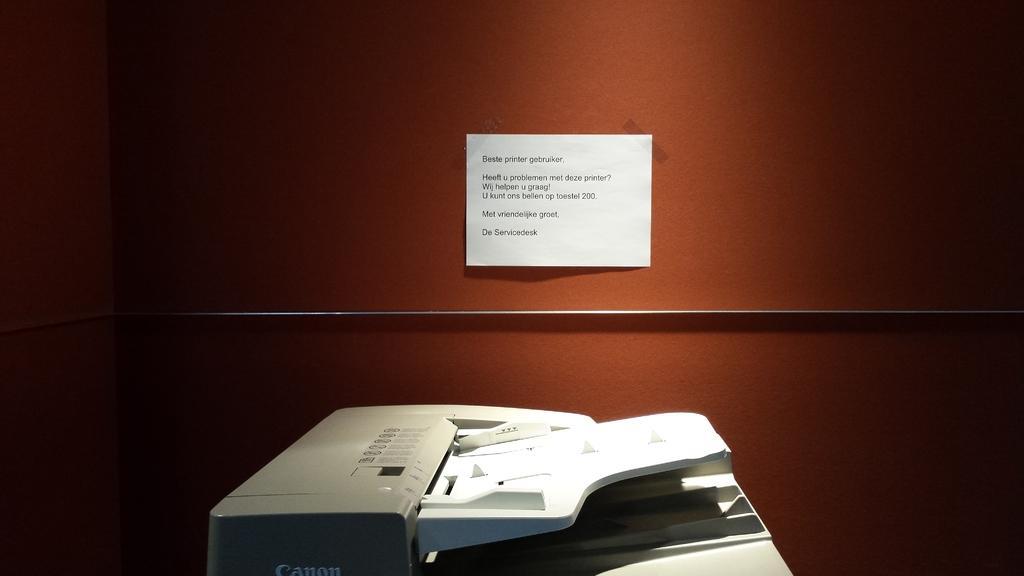In one or two sentences, can you explain what this image depicts? In the center of the image there is a xerox machine. In the background of the image there is a wall. There is a paper with some text on the wall. 